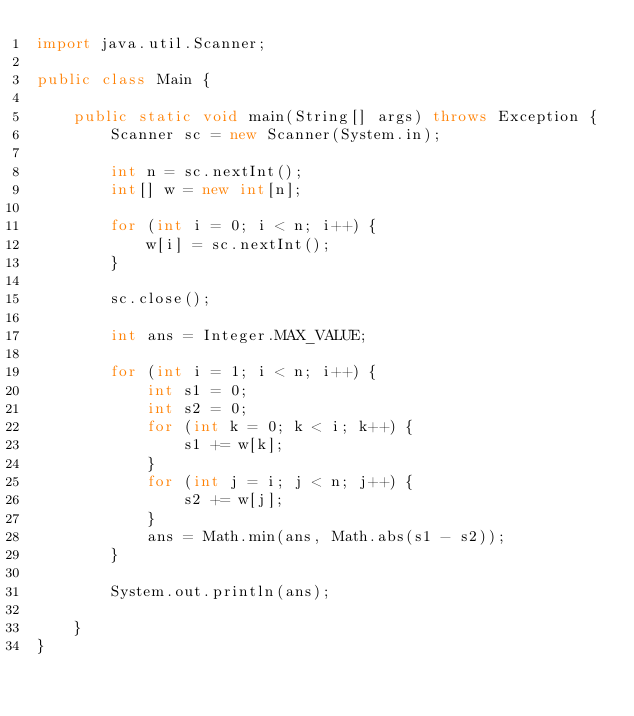<code> <loc_0><loc_0><loc_500><loc_500><_Java_>import java.util.Scanner;

public class Main {

    public static void main(String[] args) throws Exception {
        Scanner sc = new Scanner(System.in);

        int n = sc.nextInt();
        int[] w = new int[n];

        for (int i = 0; i < n; i++) {
            w[i] = sc.nextInt();
        }

        sc.close();

        int ans = Integer.MAX_VALUE;

        for (int i = 1; i < n; i++) {
            int s1 = 0;
            int s2 = 0;
            for (int k = 0; k < i; k++) {
                s1 += w[k];
            }
            for (int j = i; j < n; j++) {
                s2 += w[j];
            }
            ans = Math.min(ans, Math.abs(s1 - s2));
        }

        System.out.println(ans);

    }
}</code> 